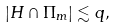Convert formula to latex. <formula><loc_0><loc_0><loc_500><loc_500>| H \cap \Pi _ { m } | \lesssim q ,</formula> 